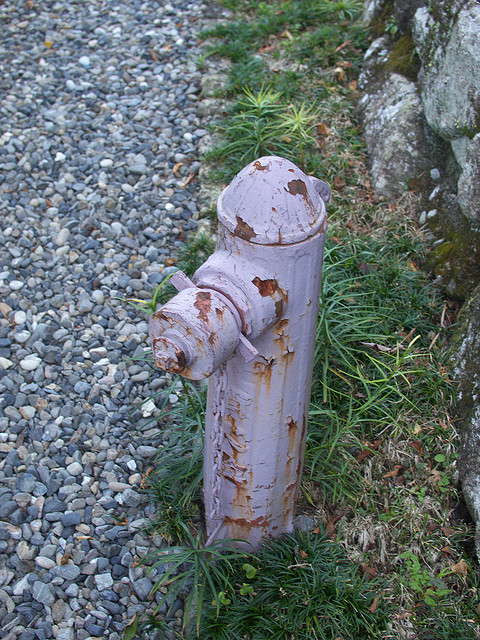What is the position of the fireplug in relation to the rock or wall? The fireplug is situated to the left of the rock or wall, and they are in close proximity to each other. 